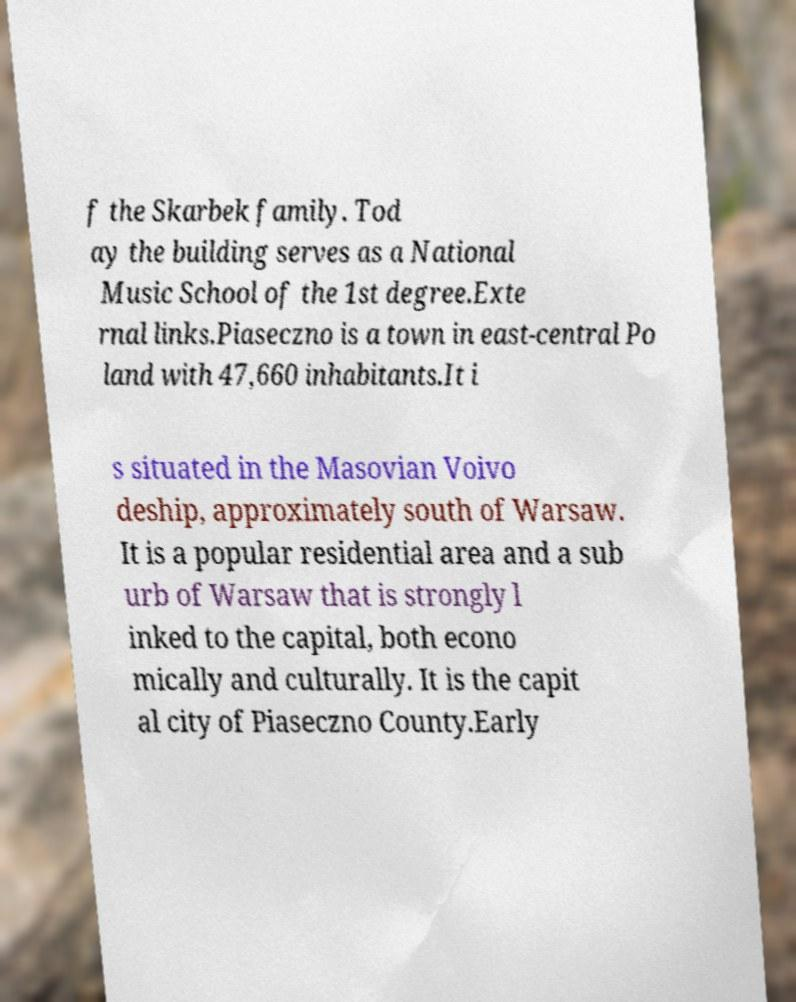For documentation purposes, I need the text within this image transcribed. Could you provide that? f the Skarbek family. Tod ay the building serves as a National Music School of the 1st degree.Exte rnal links.Piaseczno is a town in east-central Po land with 47,660 inhabitants.It i s situated in the Masovian Voivo deship, approximately south of Warsaw. It is a popular residential area and a sub urb of Warsaw that is strongly l inked to the capital, both econo mically and culturally. It is the capit al city of Piaseczno County.Early 